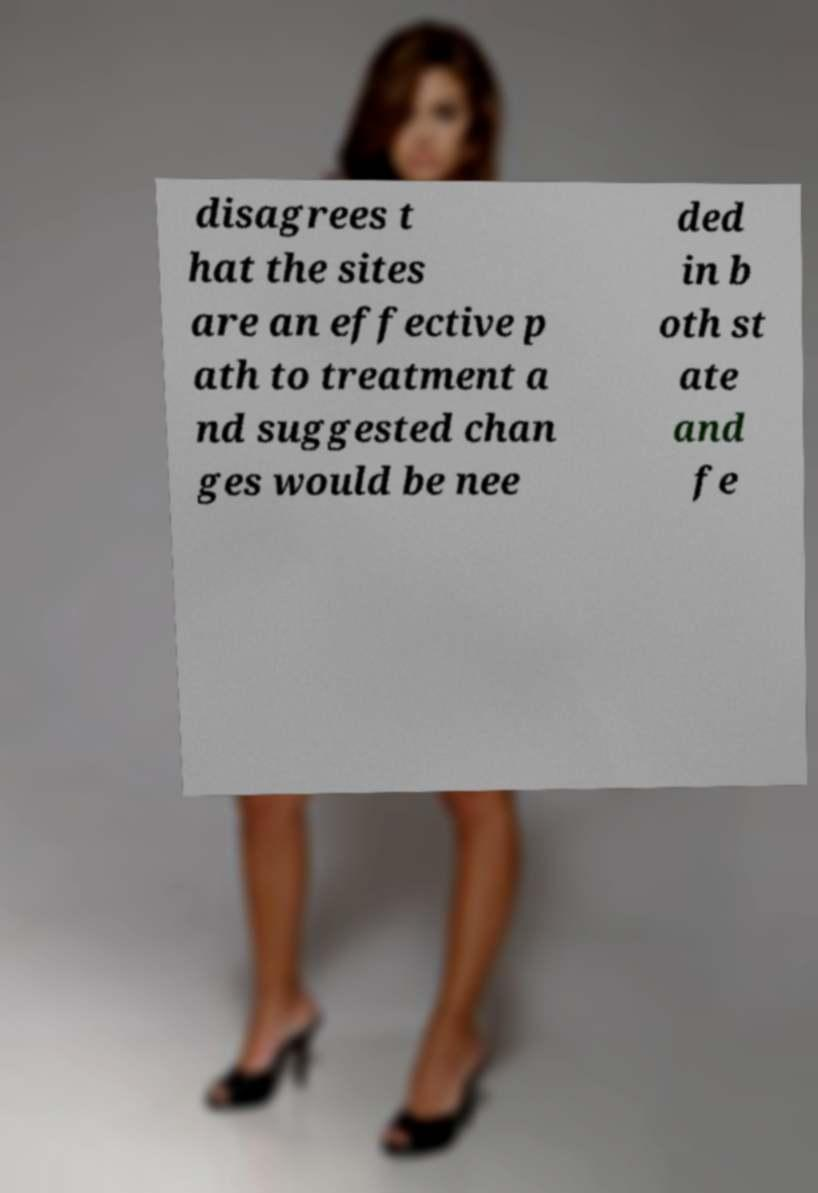There's text embedded in this image that I need extracted. Can you transcribe it verbatim? disagrees t hat the sites are an effective p ath to treatment a nd suggested chan ges would be nee ded in b oth st ate and fe 